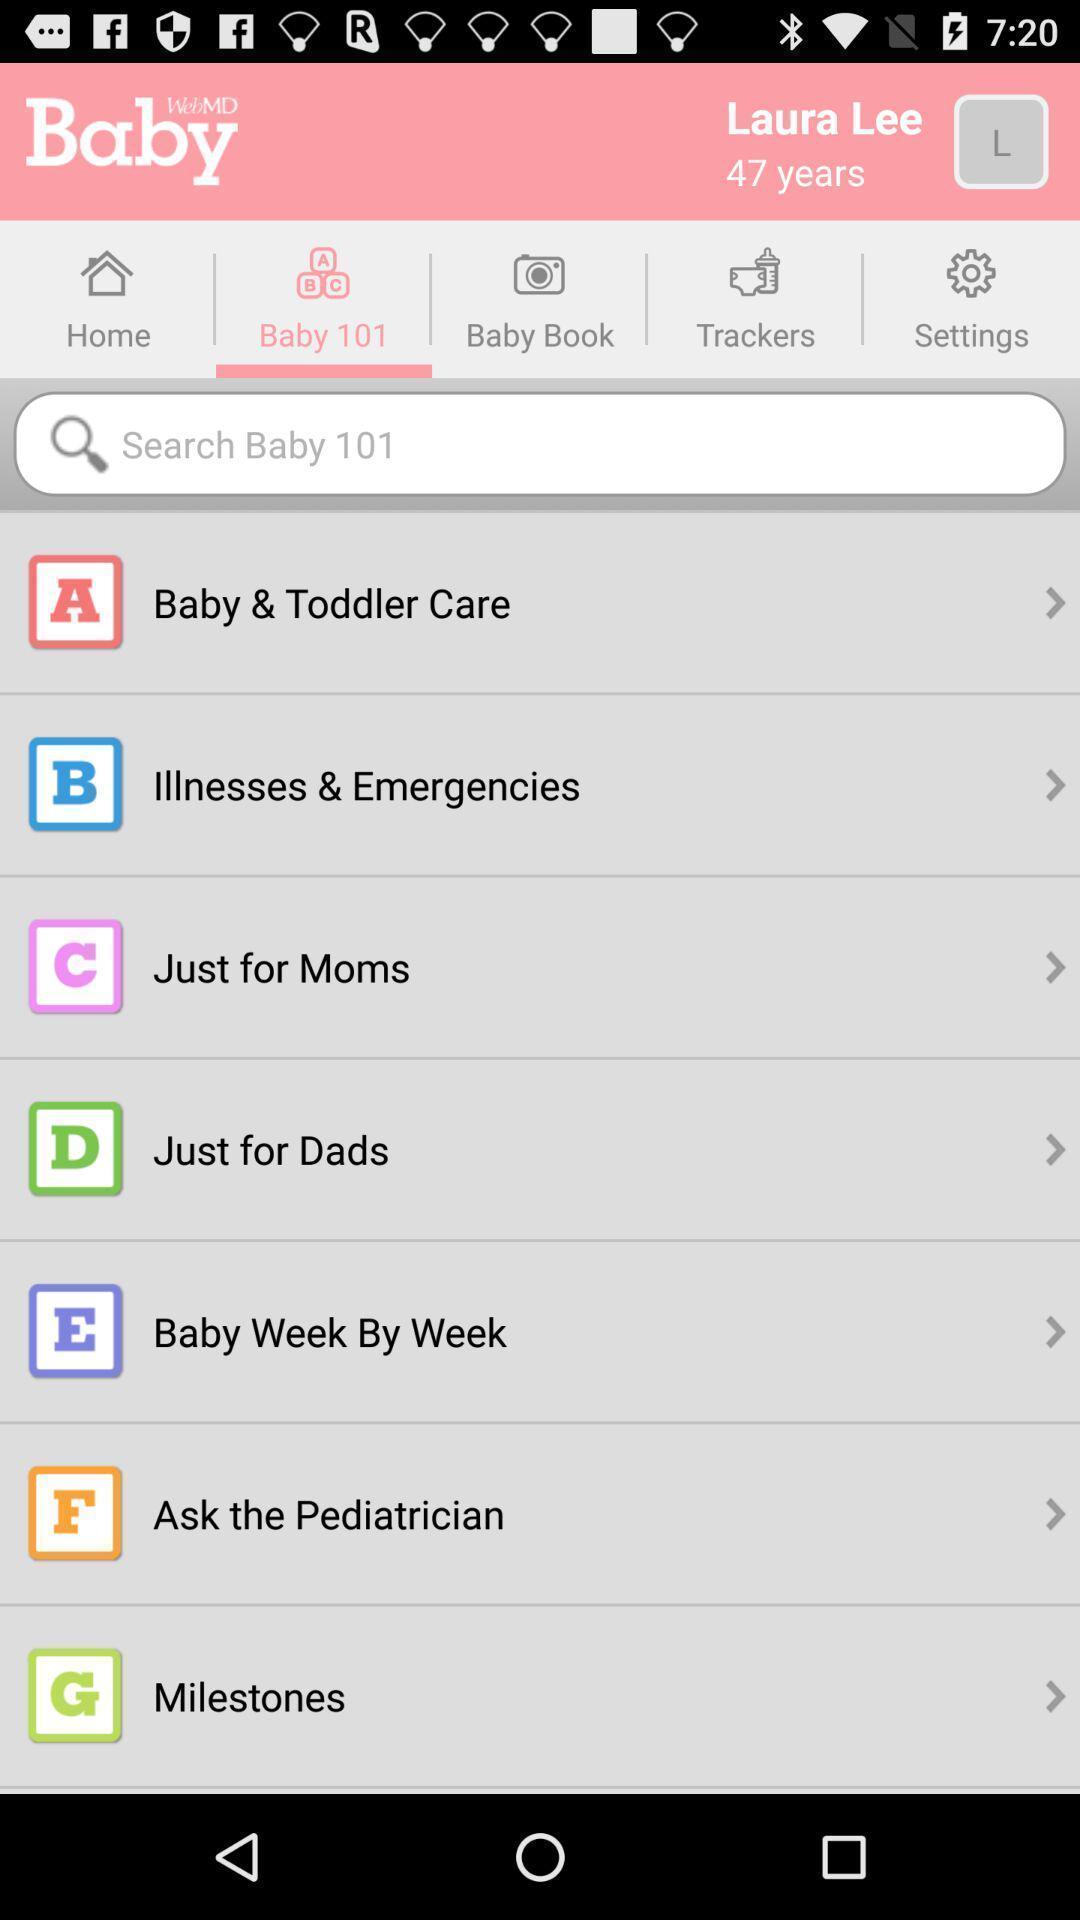Provide a textual representation of this image. Search page of a baby care app. 